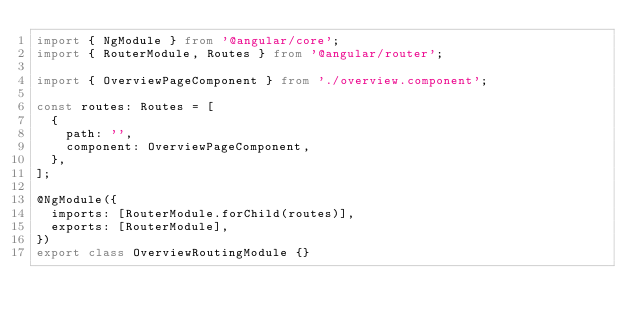Convert code to text. <code><loc_0><loc_0><loc_500><loc_500><_TypeScript_>import { NgModule } from '@angular/core';
import { RouterModule, Routes } from '@angular/router';

import { OverviewPageComponent } from './overview.component';

const routes: Routes = [
  {
    path: '',
    component: OverviewPageComponent,
  },
];

@NgModule({
  imports: [RouterModule.forChild(routes)],
  exports: [RouterModule],
})
export class OverviewRoutingModule {}
</code> 